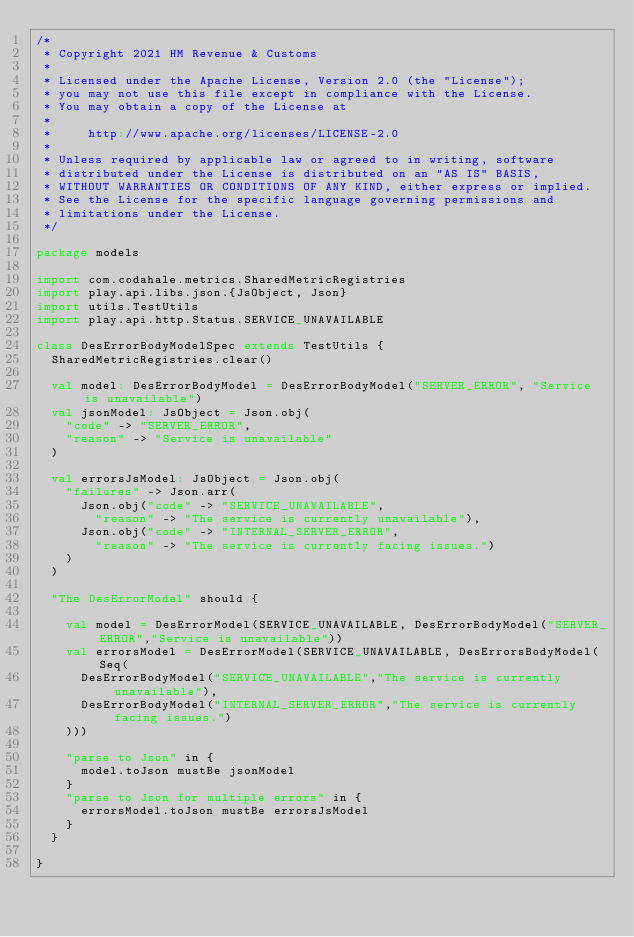<code> <loc_0><loc_0><loc_500><loc_500><_Scala_>/*
 * Copyright 2021 HM Revenue & Customs
 *
 * Licensed under the Apache License, Version 2.0 (the "License");
 * you may not use this file except in compliance with the License.
 * You may obtain a copy of the License at
 *
 *     http://www.apache.org/licenses/LICENSE-2.0
 *
 * Unless required by applicable law or agreed to in writing, software
 * distributed under the License is distributed on an "AS IS" BASIS,
 * WITHOUT WARRANTIES OR CONDITIONS OF ANY KIND, either express or implied.
 * See the License for the specific language governing permissions and
 * limitations under the License.
 */

package models

import com.codahale.metrics.SharedMetricRegistries
import play.api.libs.json.{JsObject, Json}
import utils.TestUtils
import play.api.http.Status.SERVICE_UNAVAILABLE

class DesErrorBodyModelSpec extends TestUtils {
  SharedMetricRegistries.clear()

  val model: DesErrorBodyModel = DesErrorBodyModel("SERVER_ERROR", "Service is unavailable")
  val jsonModel: JsObject = Json.obj(
    "code" -> "SERVER_ERROR",
    "reason" -> "Service is unavailable"
  )

  val errorsJsModel: JsObject = Json.obj(
    "failures" -> Json.arr(
      Json.obj("code" -> "SERVICE_UNAVAILABLE",
        "reason" -> "The service is currently unavailable"),
      Json.obj("code" -> "INTERNAL_SERVER_ERROR",
        "reason" -> "The service is currently facing issues.")
    )
  )

  "The DesErrorModel" should {

    val model = DesErrorModel(SERVICE_UNAVAILABLE, DesErrorBodyModel("SERVER_ERROR","Service is unavailable"))
    val errorsModel = DesErrorModel(SERVICE_UNAVAILABLE, DesErrorsBodyModel(Seq(
      DesErrorBodyModel("SERVICE_UNAVAILABLE","The service is currently unavailable"),
      DesErrorBodyModel("INTERNAL_SERVER_ERROR","The service is currently facing issues.")
    )))

    "parse to Json" in {
      model.toJson mustBe jsonModel
    }
    "parse to Json for multiple errors" in {
      errorsModel.toJson mustBe errorsJsModel
    }
  }

}
</code> 